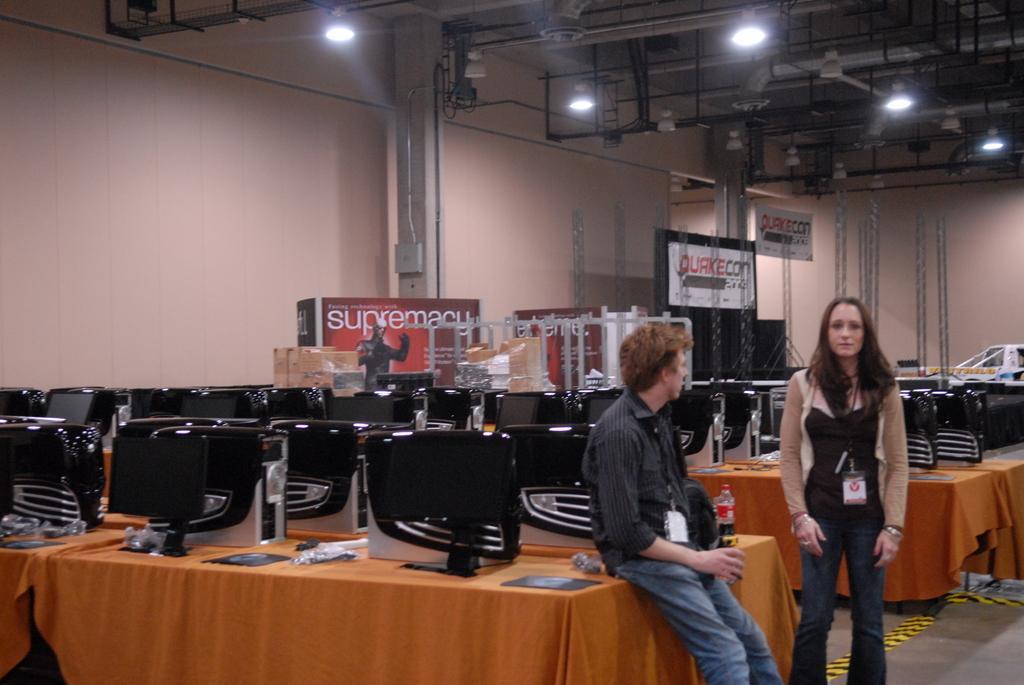Please provide a concise description of this image. In this image we can see a man and a woman standing on the floor. We can also see a group of devices and a bottle which are placed on the tables. On the backside we can see the boards with some text on them, the metal frames, cardboard boxes which are placed one on the other, a device on a pillar and a roof with some ceiling lights and metal poles. 